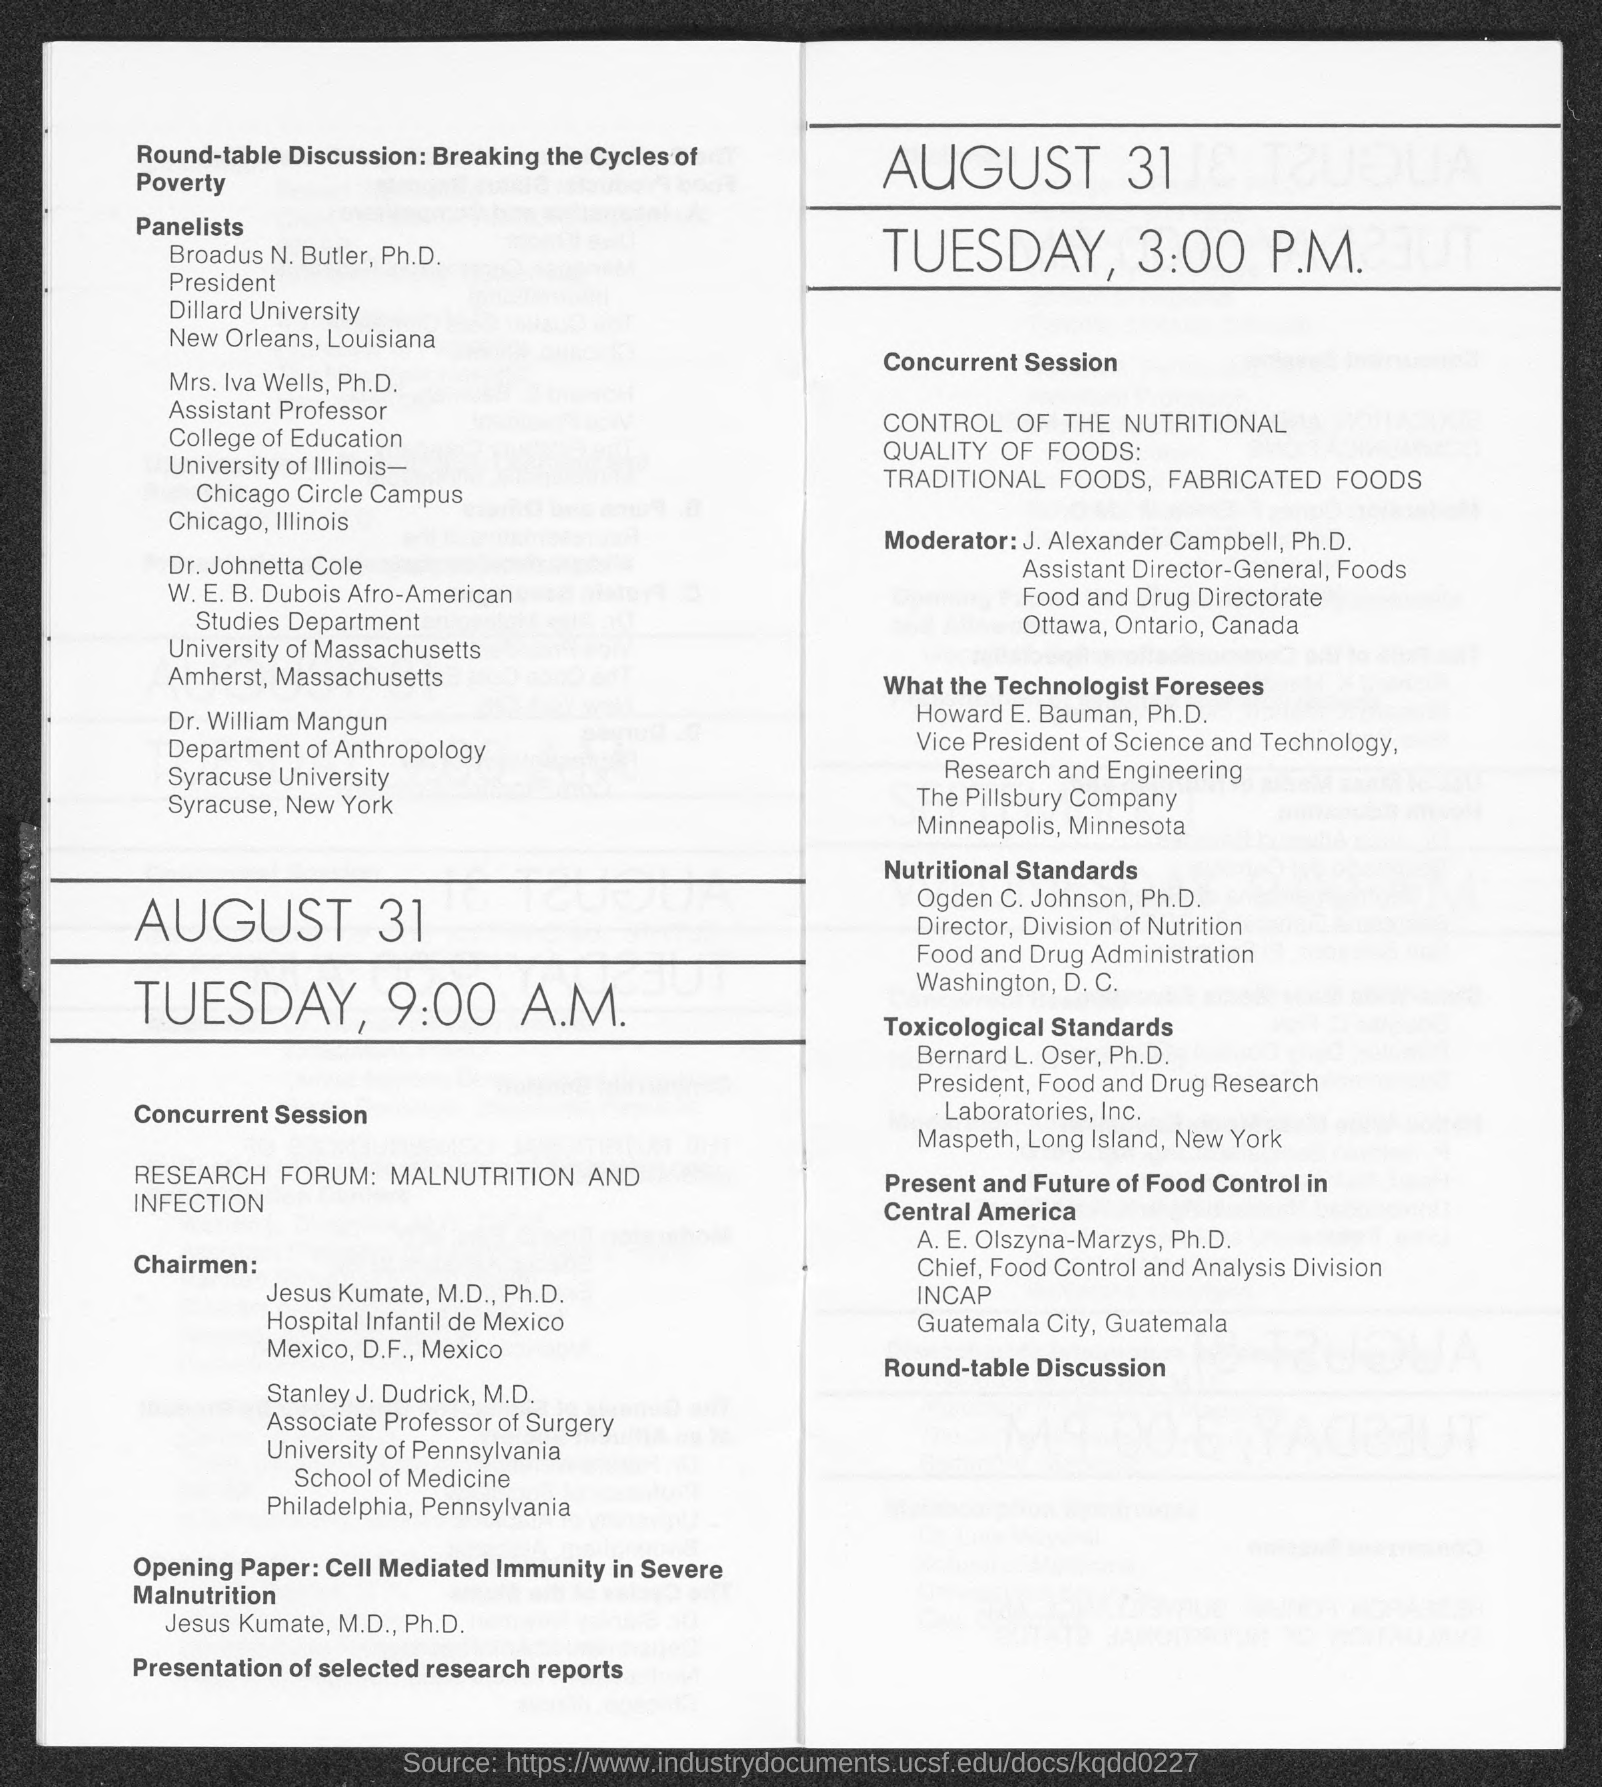Outline some significant characteristics in this image. A.E. Olszyna-Marzys holds the position of chief. Mrs. Iva Wells holds the position of an assistant professor. Ogden C. Johnson is the director of something. Broadus N. Butler is the president. Howard E. Bauman is the Vice President of Science and Technology. 